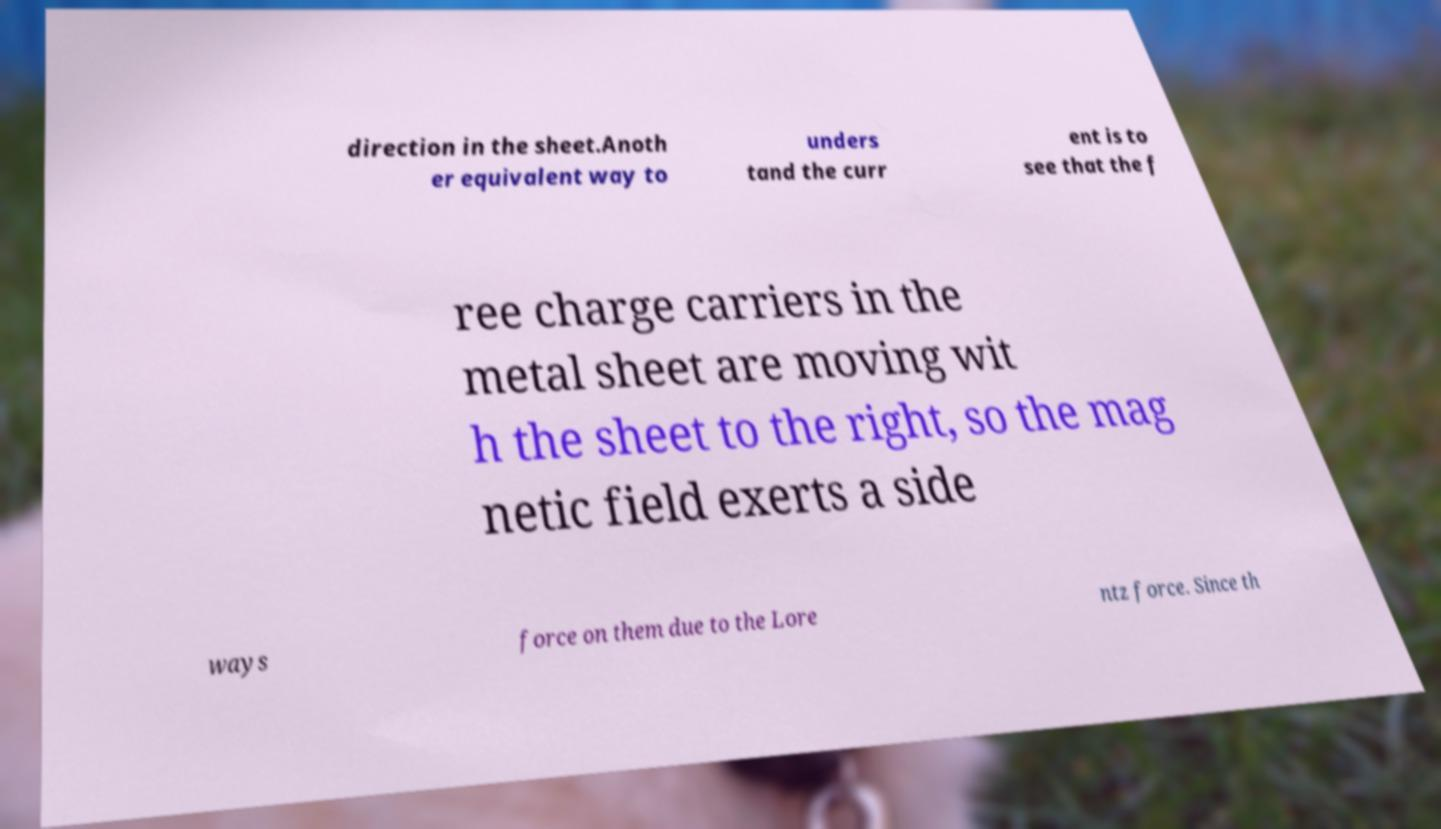Please read and relay the text visible in this image. What does it say? direction in the sheet.Anoth er equivalent way to unders tand the curr ent is to see that the f ree charge carriers in the metal sheet are moving wit h the sheet to the right, so the mag netic field exerts a side ways force on them due to the Lore ntz force. Since th 